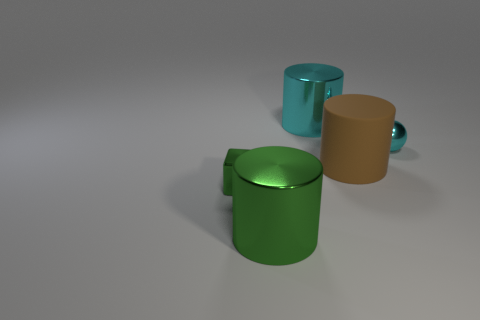Is there anything else that is the same shape as the small cyan metallic object?
Make the answer very short. No. There is a cyan object that is made of the same material as the cyan cylinder; what shape is it?
Ensure brevity in your answer.  Sphere. The large brown thing behind the big shiny cylinder on the left side of the big cyan object is made of what material?
Ensure brevity in your answer.  Rubber. Do the tiny metallic thing to the right of the rubber cylinder and the big cyan metal thing have the same shape?
Give a very brief answer. No. Is the number of tiny cyan spheres behind the cyan metallic sphere greater than the number of cyan things?
Offer a very short reply. No. Are there any other things that have the same material as the large green cylinder?
Keep it short and to the point. Yes. What number of cubes are either tiny metal things or small cyan matte things?
Keep it short and to the point. 1. There is a metal cylinder that is in front of the brown object in front of the cyan cylinder; what color is it?
Your answer should be compact. Green. There is a tiny ball; is it the same color as the large thing that is in front of the rubber cylinder?
Your answer should be very brief. No. What size is the sphere that is made of the same material as the large green cylinder?
Keep it short and to the point. Small. 